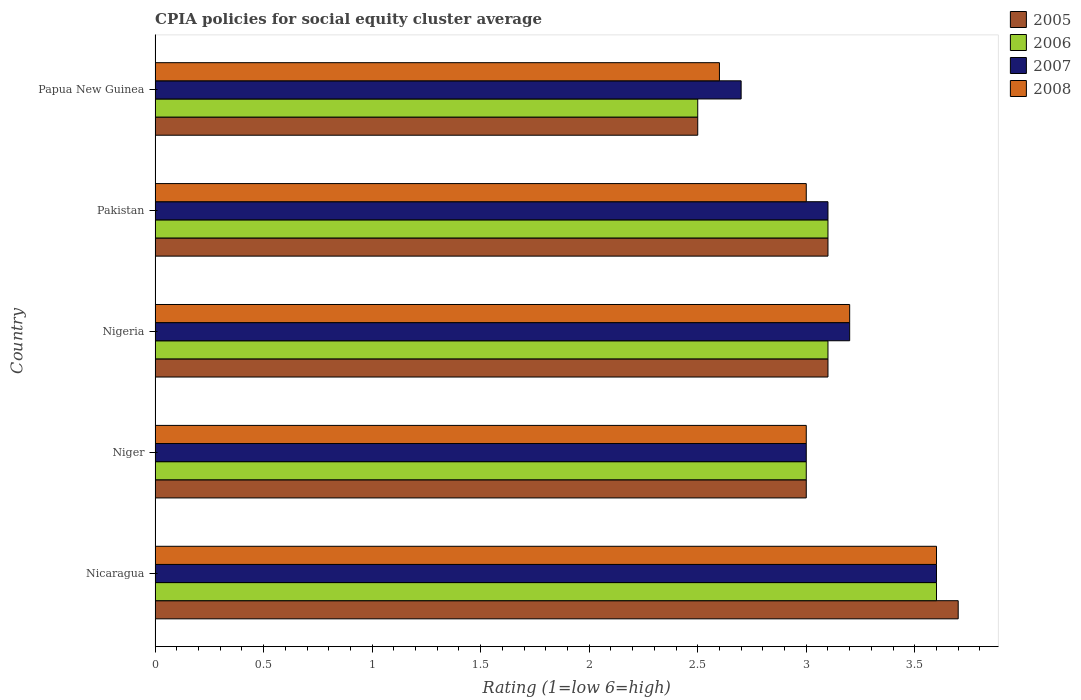Are the number of bars per tick equal to the number of legend labels?
Ensure brevity in your answer.  Yes. How many bars are there on the 2nd tick from the bottom?
Keep it short and to the point. 4. What is the label of the 4th group of bars from the top?
Your answer should be very brief. Niger. Across all countries, what is the maximum CPIA rating in 2008?
Ensure brevity in your answer.  3.6. Across all countries, what is the minimum CPIA rating in 2006?
Keep it short and to the point. 2.5. In which country was the CPIA rating in 2006 maximum?
Your answer should be compact. Nicaragua. In which country was the CPIA rating in 2008 minimum?
Provide a short and direct response. Papua New Guinea. What is the total CPIA rating in 2007 in the graph?
Give a very brief answer. 15.6. What is the difference between the CPIA rating in 2007 in Nicaragua and that in Papua New Guinea?
Offer a very short reply. 0.9. What is the difference between the CPIA rating in 2007 in Nigeria and the CPIA rating in 2006 in Niger?
Provide a short and direct response. 0.2. What is the average CPIA rating in 2007 per country?
Your answer should be compact. 3.12. What is the difference between the CPIA rating in 2005 and CPIA rating in 2007 in Nicaragua?
Ensure brevity in your answer.  0.1. What is the ratio of the CPIA rating in 2007 in Nicaragua to that in Pakistan?
Offer a very short reply. 1.16. What is the difference between the highest and the second highest CPIA rating in 2008?
Your answer should be very brief. 0.4. What is the difference between the highest and the lowest CPIA rating in 2005?
Your response must be concise. 1.2. What does the 2nd bar from the top in Niger represents?
Provide a succinct answer. 2007. Is it the case that in every country, the sum of the CPIA rating in 2008 and CPIA rating in 2007 is greater than the CPIA rating in 2006?
Provide a succinct answer. Yes. How many bars are there?
Ensure brevity in your answer.  20. Are all the bars in the graph horizontal?
Keep it short and to the point. Yes. What is the difference between two consecutive major ticks on the X-axis?
Offer a very short reply. 0.5. How are the legend labels stacked?
Offer a very short reply. Vertical. What is the title of the graph?
Provide a short and direct response. CPIA policies for social equity cluster average. Does "1963" appear as one of the legend labels in the graph?
Offer a very short reply. No. What is the label or title of the X-axis?
Your response must be concise. Rating (1=low 6=high). What is the label or title of the Y-axis?
Offer a terse response. Country. What is the Rating (1=low 6=high) in 2005 in Nicaragua?
Provide a short and direct response. 3.7. What is the Rating (1=low 6=high) in 2006 in Nicaragua?
Provide a succinct answer. 3.6. What is the Rating (1=low 6=high) in 2008 in Nicaragua?
Give a very brief answer. 3.6. What is the Rating (1=low 6=high) in 2005 in Niger?
Your response must be concise. 3. What is the Rating (1=low 6=high) of 2007 in Niger?
Your answer should be compact. 3. What is the Rating (1=low 6=high) in 2006 in Nigeria?
Your answer should be very brief. 3.1. What is the Rating (1=low 6=high) of 2006 in Pakistan?
Provide a short and direct response. 3.1. What is the Rating (1=low 6=high) of 2007 in Papua New Guinea?
Offer a terse response. 2.7. What is the Rating (1=low 6=high) of 2008 in Papua New Guinea?
Provide a short and direct response. 2.6. Across all countries, what is the maximum Rating (1=low 6=high) in 2006?
Offer a very short reply. 3.6. Across all countries, what is the maximum Rating (1=low 6=high) of 2007?
Offer a very short reply. 3.6. Across all countries, what is the maximum Rating (1=low 6=high) of 2008?
Offer a terse response. 3.6. Across all countries, what is the minimum Rating (1=low 6=high) of 2005?
Provide a short and direct response. 2.5. Across all countries, what is the minimum Rating (1=low 6=high) in 2007?
Give a very brief answer. 2.7. What is the total Rating (1=low 6=high) of 2006 in the graph?
Provide a short and direct response. 15.3. What is the difference between the Rating (1=low 6=high) of 2005 in Nicaragua and that in Niger?
Offer a very short reply. 0.7. What is the difference between the Rating (1=low 6=high) in 2006 in Nicaragua and that in Niger?
Your answer should be very brief. 0.6. What is the difference between the Rating (1=low 6=high) of 2007 in Nicaragua and that in Niger?
Give a very brief answer. 0.6. What is the difference between the Rating (1=low 6=high) of 2008 in Nicaragua and that in Niger?
Offer a terse response. 0.6. What is the difference between the Rating (1=low 6=high) of 2005 in Nicaragua and that in Nigeria?
Ensure brevity in your answer.  0.6. What is the difference between the Rating (1=low 6=high) in 2006 in Nicaragua and that in Nigeria?
Your answer should be very brief. 0.5. What is the difference between the Rating (1=low 6=high) of 2005 in Nicaragua and that in Pakistan?
Offer a very short reply. 0.6. What is the difference between the Rating (1=low 6=high) in 2006 in Nicaragua and that in Pakistan?
Give a very brief answer. 0.5. What is the difference between the Rating (1=low 6=high) of 2007 in Nicaragua and that in Pakistan?
Your answer should be compact. 0.5. What is the difference between the Rating (1=low 6=high) of 2008 in Nicaragua and that in Pakistan?
Make the answer very short. 0.6. What is the difference between the Rating (1=low 6=high) of 2005 in Nicaragua and that in Papua New Guinea?
Your answer should be compact. 1.2. What is the difference between the Rating (1=low 6=high) in 2008 in Nicaragua and that in Papua New Guinea?
Make the answer very short. 1. What is the difference between the Rating (1=low 6=high) in 2008 in Niger and that in Nigeria?
Make the answer very short. -0.2. What is the difference between the Rating (1=low 6=high) in 2005 in Niger and that in Pakistan?
Provide a short and direct response. -0.1. What is the difference between the Rating (1=low 6=high) of 2007 in Nigeria and that in Pakistan?
Your answer should be very brief. 0.1. What is the difference between the Rating (1=low 6=high) of 2008 in Nigeria and that in Pakistan?
Provide a succinct answer. 0.2. What is the difference between the Rating (1=low 6=high) in 2005 in Nigeria and that in Papua New Guinea?
Offer a terse response. 0.6. What is the difference between the Rating (1=low 6=high) in 2006 in Nigeria and that in Papua New Guinea?
Offer a very short reply. 0.6. What is the difference between the Rating (1=low 6=high) in 2008 in Nigeria and that in Papua New Guinea?
Your response must be concise. 0.6. What is the difference between the Rating (1=low 6=high) in 2005 in Pakistan and that in Papua New Guinea?
Offer a very short reply. 0.6. What is the difference between the Rating (1=low 6=high) of 2006 in Pakistan and that in Papua New Guinea?
Your answer should be compact. 0.6. What is the difference between the Rating (1=low 6=high) of 2007 in Pakistan and that in Papua New Guinea?
Your answer should be very brief. 0.4. What is the difference between the Rating (1=low 6=high) in 2008 in Pakistan and that in Papua New Guinea?
Offer a very short reply. 0.4. What is the difference between the Rating (1=low 6=high) in 2005 in Nicaragua and the Rating (1=low 6=high) in 2006 in Niger?
Offer a very short reply. 0.7. What is the difference between the Rating (1=low 6=high) of 2005 in Nicaragua and the Rating (1=low 6=high) of 2008 in Niger?
Provide a succinct answer. 0.7. What is the difference between the Rating (1=low 6=high) of 2006 in Nicaragua and the Rating (1=low 6=high) of 2008 in Niger?
Offer a very short reply. 0.6. What is the difference between the Rating (1=low 6=high) of 2007 in Nicaragua and the Rating (1=low 6=high) of 2008 in Niger?
Your response must be concise. 0.6. What is the difference between the Rating (1=low 6=high) of 2005 in Nicaragua and the Rating (1=low 6=high) of 2006 in Pakistan?
Your response must be concise. 0.6. What is the difference between the Rating (1=low 6=high) of 2005 in Nicaragua and the Rating (1=low 6=high) of 2008 in Pakistan?
Provide a short and direct response. 0.7. What is the difference between the Rating (1=low 6=high) in 2006 in Nicaragua and the Rating (1=low 6=high) in 2007 in Pakistan?
Your response must be concise. 0.5. What is the difference between the Rating (1=low 6=high) of 2007 in Nicaragua and the Rating (1=low 6=high) of 2008 in Pakistan?
Your answer should be very brief. 0.6. What is the difference between the Rating (1=low 6=high) of 2005 in Nicaragua and the Rating (1=low 6=high) of 2007 in Papua New Guinea?
Offer a very short reply. 1. What is the difference between the Rating (1=low 6=high) of 2006 in Nicaragua and the Rating (1=low 6=high) of 2007 in Papua New Guinea?
Your answer should be compact. 0.9. What is the difference between the Rating (1=low 6=high) of 2006 in Nicaragua and the Rating (1=low 6=high) of 2008 in Papua New Guinea?
Your answer should be compact. 1. What is the difference between the Rating (1=low 6=high) in 2007 in Nicaragua and the Rating (1=low 6=high) in 2008 in Papua New Guinea?
Ensure brevity in your answer.  1. What is the difference between the Rating (1=low 6=high) of 2005 in Niger and the Rating (1=low 6=high) of 2007 in Nigeria?
Your answer should be compact. -0.2. What is the difference between the Rating (1=low 6=high) in 2005 in Niger and the Rating (1=low 6=high) in 2008 in Pakistan?
Make the answer very short. 0. What is the difference between the Rating (1=low 6=high) in 2006 in Niger and the Rating (1=low 6=high) in 2007 in Pakistan?
Make the answer very short. -0.1. What is the difference between the Rating (1=low 6=high) of 2006 in Niger and the Rating (1=low 6=high) of 2008 in Pakistan?
Provide a succinct answer. 0. What is the difference between the Rating (1=low 6=high) of 2005 in Niger and the Rating (1=low 6=high) of 2008 in Papua New Guinea?
Provide a short and direct response. 0.4. What is the difference between the Rating (1=low 6=high) in 2006 in Niger and the Rating (1=low 6=high) in 2007 in Papua New Guinea?
Your answer should be compact. 0.3. What is the difference between the Rating (1=low 6=high) in 2005 in Nigeria and the Rating (1=low 6=high) in 2007 in Pakistan?
Your response must be concise. 0. What is the difference between the Rating (1=low 6=high) of 2006 in Nigeria and the Rating (1=low 6=high) of 2007 in Pakistan?
Keep it short and to the point. 0. What is the difference between the Rating (1=low 6=high) in 2006 in Nigeria and the Rating (1=low 6=high) in 2008 in Pakistan?
Keep it short and to the point. 0.1. What is the difference between the Rating (1=low 6=high) of 2007 in Nigeria and the Rating (1=low 6=high) of 2008 in Pakistan?
Your response must be concise. 0.2. What is the difference between the Rating (1=low 6=high) of 2005 in Nigeria and the Rating (1=low 6=high) of 2006 in Papua New Guinea?
Your answer should be compact. 0.6. What is the difference between the Rating (1=low 6=high) of 2005 in Nigeria and the Rating (1=low 6=high) of 2008 in Papua New Guinea?
Keep it short and to the point. 0.5. What is the difference between the Rating (1=low 6=high) of 2006 in Nigeria and the Rating (1=low 6=high) of 2007 in Papua New Guinea?
Provide a short and direct response. 0.4. What is the difference between the Rating (1=low 6=high) in 2005 in Pakistan and the Rating (1=low 6=high) in 2006 in Papua New Guinea?
Provide a succinct answer. 0.6. What is the difference between the Rating (1=low 6=high) of 2005 in Pakistan and the Rating (1=low 6=high) of 2007 in Papua New Guinea?
Provide a succinct answer. 0.4. What is the difference between the Rating (1=low 6=high) of 2005 in Pakistan and the Rating (1=low 6=high) of 2008 in Papua New Guinea?
Provide a succinct answer. 0.5. What is the difference between the Rating (1=low 6=high) in 2006 in Pakistan and the Rating (1=low 6=high) in 2007 in Papua New Guinea?
Make the answer very short. 0.4. What is the difference between the Rating (1=low 6=high) in 2007 in Pakistan and the Rating (1=low 6=high) in 2008 in Papua New Guinea?
Your response must be concise. 0.5. What is the average Rating (1=low 6=high) of 2005 per country?
Provide a short and direct response. 3.08. What is the average Rating (1=low 6=high) of 2006 per country?
Provide a succinct answer. 3.06. What is the average Rating (1=low 6=high) of 2007 per country?
Make the answer very short. 3.12. What is the average Rating (1=low 6=high) of 2008 per country?
Provide a short and direct response. 3.08. What is the difference between the Rating (1=low 6=high) in 2005 and Rating (1=low 6=high) in 2008 in Nicaragua?
Offer a very short reply. 0.1. What is the difference between the Rating (1=low 6=high) in 2006 and Rating (1=low 6=high) in 2007 in Nicaragua?
Make the answer very short. 0. What is the difference between the Rating (1=low 6=high) of 2005 and Rating (1=low 6=high) of 2006 in Niger?
Make the answer very short. 0. What is the difference between the Rating (1=low 6=high) of 2005 and Rating (1=low 6=high) of 2007 in Niger?
Offer a very short reply. 0. What is the difference between the Rating (1=low 6=high) of 2006 and Rating (1=low 6=high) of 2008 in Niger?
Ensure brevity in your answer.  0. What is the difference between the Rating (1=low 6=high) in 2007 and Rating (1=low 6=high) in 2008 in Niger?
Your answer should be very brief. 0. What is the difference between the Rating (1=low 6=high) of 2005 and Rating (1=low 6=high) of 2006 in Nigeria?
Make the answer very short. 0. What is the difference between the Rating (1=low 6=high) in 2006 and Rating (1=low 6=high) in 2007 in Nigeria?
Give a very brief answer. -0.1. What is the difference between the Rating (1=low 6=high) in 2006 and Rating (1=low 6=high) in 2008 in Nigeria?
Provide a succinct answer. -0.1. What is the difference between the Rating (1=low 6=high) of 2007 and Rating (1=low 6=high) of 2008 in Nigeria?
Provide a succinct answer. 0. What is the difference between the Rating (1=low 6=high) in 2005 and Rating (1=low 6=high) in 2006 in Pakistan?
Your answer should be very brief. 0. What is the difference between the Rating (1=low 6=high) of 2005 and Rating (1=low 6=high) of 2008 in Pakistan?
Ensure brevity in your answer.  0.1. What is the difference between the Rating (1=low 6=high) in 2007 and Rating (1=low 6=high) in 2008 in Pakistan?
Your answer should be very brief. 0.1. What is the difference between the Rating (1=low 6=high) in 2005 and Rating (1=low 6=high) in 2006 in Papua New Guinea?
Your answer should be compact. 0. What is the difference between the Rating (1=low 6=high) in 2007 and Rating (1=low 6=high) in 2008 in Papua New Guinea?
Ensure brevity in your answer.  0.1. What is the ratio of the Rating (1=low 6=high) of 2005 in Nicaragua to that in Niger?
Make the answer very short. 1.23. What is the ratio of the Rating (1=low 6=high) of 2007 in Nicaragua to that in Niger?
Provide a short and direct response. 1.2. What is the ratio of the Rating (1=low 6=high) in 2008 in Nicaragua to that in Niger?
Keep it short and to the point. 1.2. What is the ratio of the Rating (1=low 6=high) in 2005 in Nicaragua to that in Nigeria?
Give a very brief answer. 1.19. What is the ratio of the Rating (1=low 6=high) of 2006 in Nicaragua to that in Nigeria?
Your response must be concise. 1.16. What is the ratio of the Rating (1=low 6=high) in 2008 in Nicaragua to that in Nigeria?
Provide a succinct answer. 1.12. What is the ratio of the Rating (1=low 6=high) in 2005 in Nicaragua to that in Pakistan?
Your answer should be very brief. 1.19. What is the ratio of the Rating (1=low 6=high) in 2006 in Nicaragua to that in Pakistan?
Ensure brevity in your answer.  1.16. What is the ratio of the Rating (1=low 6=high) of 2007 in Nicaragua to that in Pakistan?
Make the answer very short. 1.16. What is the ratio of the Rating (1=low 6=high) of 2008 in Nicaragua to that in Pakistan?
Offer a terse response. 1.2. What is the ratio of the Rating (1=low 6=high) in 2005 in Nicaragua to that in Papua New Guinea?
Your response must be concise. 1.48. What is the ratio of the Rating (1=low 6=high) of 2006 in Nicaragua to that in Papua New Guinea?
Your answer should be very brief. 1.44. What is the ratio of the Rating (1=low 6=high) in 2007 in Nicaragua to that in Papua New Guinea?
Ensure brevity in your answer.  1.33. What is the ratio of the Rating (1=low 6=high) of 2008 in Nicaragua to that in Papua New Guinea?
Keep it short and to the point. 1.38. What is the ratio of the Rating (1=low 6=high) of 2005 in Niger to that in Nigeria?
Keep it short and to the point. 0.97. What is the ratio of the Rating (1=low 6=high) in 2006 in Niger to that in Nigeria?
Provide a succinct answer. 0.97. What is the ratio of the Rating (1=low 6=high) in 2007 in Niger to that in Nigeria?
Provide a short and direct response. 0.94. What is the ratio of the Rating (1=low 6=high) of 2008 in Niger to that in Nigeria?
Your answer should be compact. 0.94. What is the ratio of the Rating (1=low 6=high) of 2007 in Niger to that in Pakistan?
Offer a very short reply. 0.97. What is the ratio of the Rating (1=low 6=high) in 2008 in Niger to that in Pakistan?
Make the answer very short. 1. What is the ratio of the Rating (1=low 6=high) in 2005 in Niger to that in Papua New Guinea?
Offer a terse response. 1.2. What is the ratio of the Rating (1=low 6=high) in 2007 in Niger to that in Papua New Guinea?
Offer a very short reply. 1.11. What is the ratio of the Rating (1=low 6=high) of 2008 in Niger to that in Papua New Guinea?
Offer a very short reply. 1.15. What is the ratio of the Rating (1=low 6=high) in 2005 in Nigeria to that in Pakistan?
Provide a short and direct response. 1. What is the ratio of the Rating (1=low 6=high) in 2006 in Nigeria to that in Pakistan?
Your answer should be compact. 1. What is the ratio of the Rating (1=low 6=high) of 2007 in Nigeria to that in Pakistan?
Ensure brevity in your answer.  1.03. What is the ratio of the Rating (1=low 6=high) in 2008 in Nigeria to that in Pakistan?
Ensure brevity in your answer.  1.07. What is the ratio of the Rating (1=low 6=high) in 2005 in Nigeria to that in Papua New Guinea?
Provide a succinct answer. 1.24. What is the ratio of the Rating (1=low 6=high) in 2006 in Nigeria to that in Papua New Guinea?
Provide a short and direct response. 1.24. What is the ratio of the Rating (1=low 6=high) of 2007 in Nigeria to that in Papua New Guinea?
Give a very brief answer. 1.19. What is the ratio of the Rating (1=low 6=high) of 2008 in Nigeria to that in Papua New Guinea?
Provide a short and direct response. 1.23. What is the ratio of the Rating (1=low 6=high) of 2005 in Pakistan to that in Papua New Guinea?
Your answer should be very brief. 1.24. What is the ratio of the Rating (1=low 6=high) of 2006 in Pakistan to that in Papua New Guinea?
Make the answer very short. 1.24. What is the ratio of the Rating (1=low 6=high) in 2007 in Pakistan to that in Papua New Guinea?
Ensure brevity in your answer.  1.15. What is the ratio of the Rating (1=low 6=high) in 2008 in Pakistan to that in Papua New Guinea?
Provide a short and direct response. 1.15. What is the difference between the highest and the lowest Rating (1=low 6=high) in 2005?
Ensure brevity in your answer.  1.2. What is the difference between the highest and the lowest Rating (1=low 6=high) in 2006?
Offer a terse response. 1.1. What is the difference between the highest and the lowest Rating (1=low 6=high) of 2007?
Your answer should be compact. 0.9. 